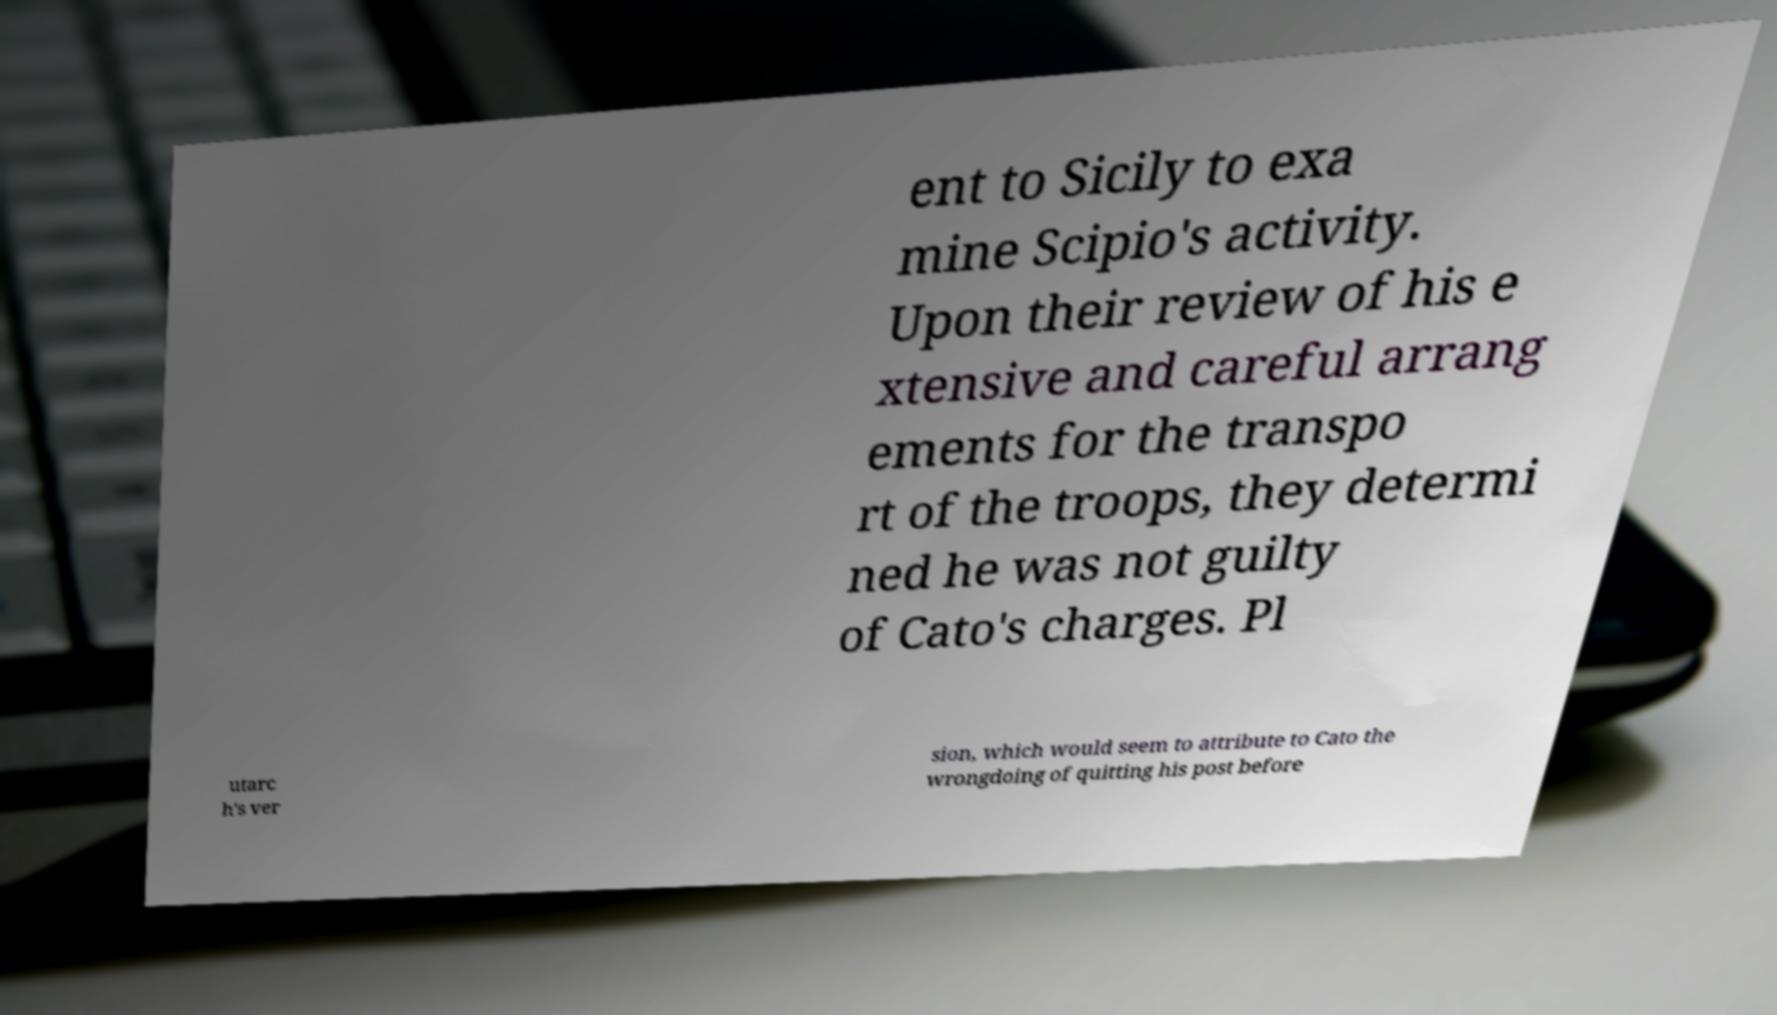There's text embedded in this image that I need extracted. Can you transcribe it verbatim? ent to Sicily to exa mine Scipio's activity. Upon their review of his e xtensive and careful arrang ements for the transpo rt of the troops, they determi ned he was not guilty of Cato's charges. Pl utarc h's ver sion, which would seem to attribute to Cato the wrongdoing of quitting his post before 